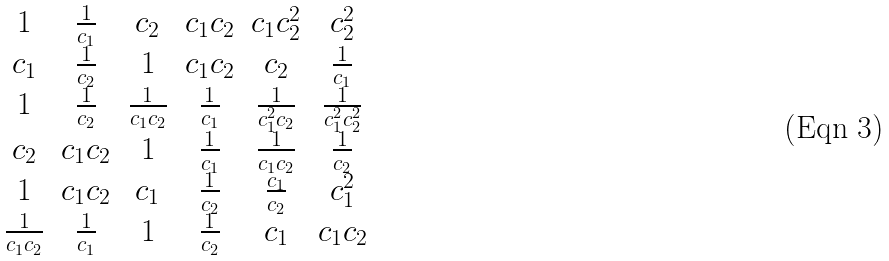Convert formula to latex. <formula><loc_0><loc_0><loc_500><loc_500>\begin{matrix} 1 & \frac { 1 } { c _ { 1 } } & c _ { 2 } & c _ { 1 } c _ { 2 } & c _ { 1 } c _ { 2 } ^ { 2 } & c _ { 2 } ^ { 2 } \\ c _ { 1 } & \frac { 1 } { c _ { 2 } } & 1 & c _ { 1 } c _ { 2 } & c _ { 2 } & \frac { 1 } { c _ { 1 } } \\ 1 & \frac { 1 } { c _ { 2 } } & \frac { 1 } { c _ { 1 } c _ { 2 } } & \frac { 1 } { c _ { 1 } } & \frac { 1 } { c _ { 1 } ^ { 2 } c _ { 2 } } & \frac { 1 } { c _ { 1 } ^ { 2 } c _ { 2 } ^ { 2 } } \\ c _ { 2 } & c _ { 1 } c _ { 2 } & 1 & \frac { 1 } { c _ { 1 } } & \frac { 1 } { c _ { 1 } c _ { 2 } } & \frac { 1 } { c _ { 2 } } \\ 1 & c _ { 1 } c _ { 2 } & c _ { 1 } & \frac { 1 } { c _ { 2 } } & \frac { c _ { 1 } } { c _ { 2 } } & c _ { 1 } ^ { 2 } \\ \frac { 1 } { c _ { 1 } c _ { 2 } } & \frac { 1 } { c _ { 1 } } & 1 & \frac { 1 } { c _ { 2 } } & c _ { 1 } & c _ { 1 } c _ { 2 } \end{matrix}</formula> 